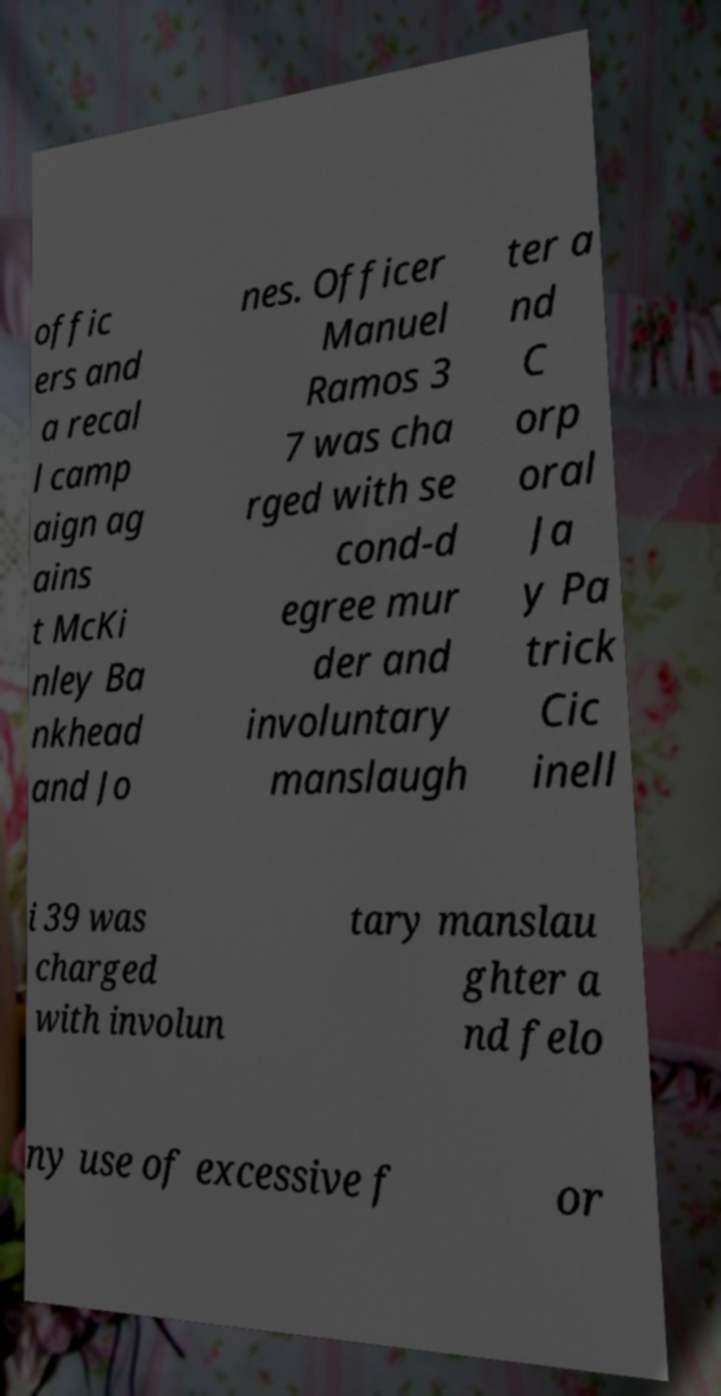Please identify and transcribe the text found in this image. offic ers and a recal l camp aign ag ains t McKi nley Ba nkhead and Jo nes. Officer Manuel Ramos 3 7 was cha rged with se cond-d egree mur der and involuntary manslaugh ter a nd C orp oral Ja y Pa trick Cic inell i 39 was charged with involun tary manslau ghter a nd felo ny use of excessive f or 